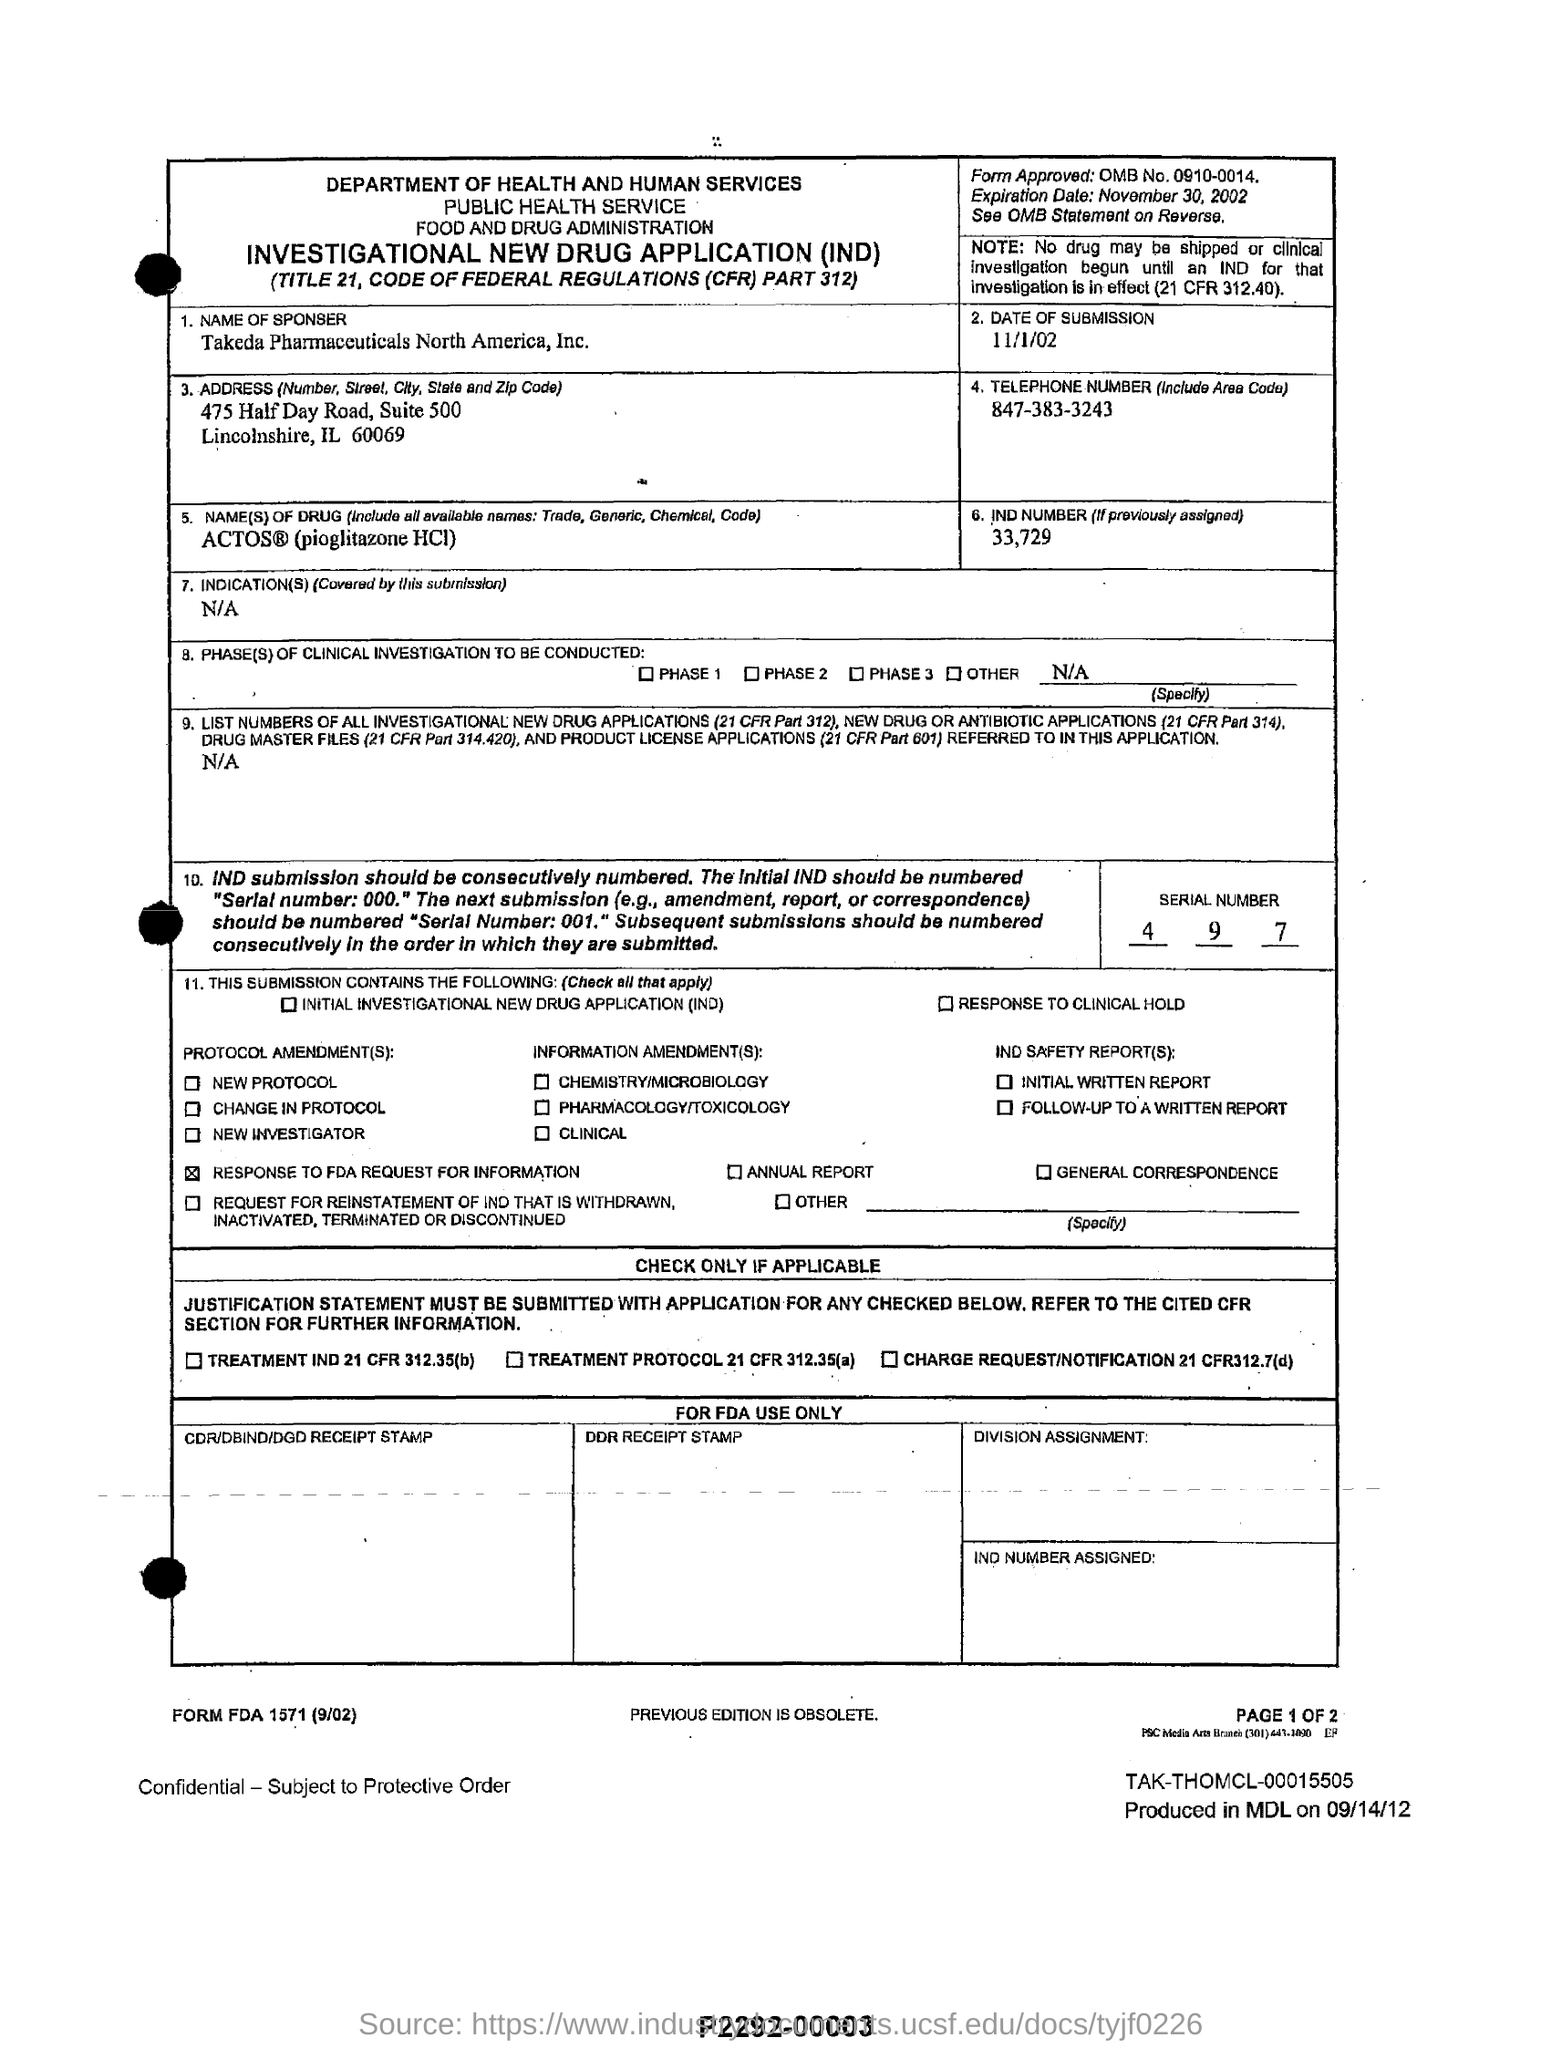List a handful of essential elements in this visual. The date of submission is November 1st, 2002. The drug ACTOS, which is commonly referred to as pioglitazone HCI, is its name. The serial number mentioned in the form is 4, 9, 7. The form with the approved form is OMB No. 0910-0014. The number IND 33,729, if previously assigned, would be expressed as "the number 33,729, if previously assigned. 